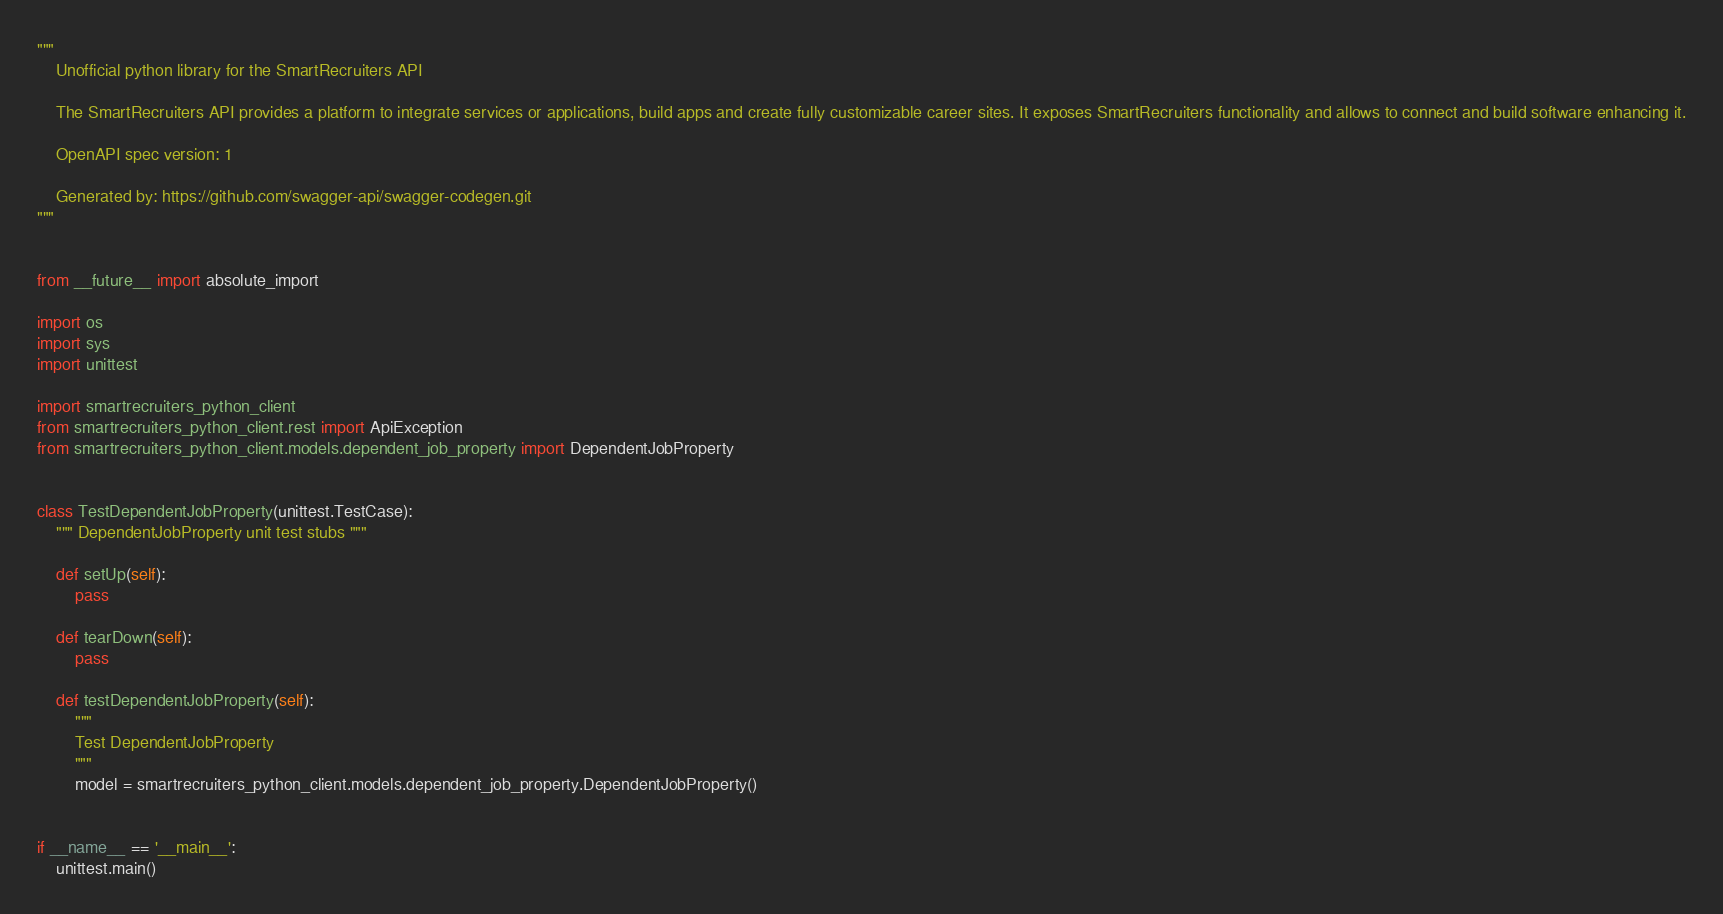<code> <loc_0><loc_0><loc_500><loc_500><_Python_>"""
    Unofficial python library for the SmartRecruiters API

    The SmartRecruiters API provides a platform to integrate services or applications, build apps and create fully customizable career sites. It exposes SmartRecruiters functionality and allows to connect and build software enhancing it.

    OpenAPI spec version: 1
    
    Generated by: https://github.com/swagger-api/swagger-codegen.git
"""


from __future__ import absolute_import

import os
import sys
import unittest

import smartrecruiters_python_client
from smartrecruiters_python_client.rest import ApiException
from smartrecruiters_python_client.models.dependent_job_property import DependentJobProperty


class TestDependentJobProperty(unittest.TestCase):
    """ DependentJobProperty unit test stubs """

    def setUp(self):
        pass

    def tearDown(self):
        pass

    def testDependentJobProperty(self):
        """
        Test DependentJobProperty
        """
        model = smartrecruiters_python_client.models.dependent_job_property.DependentJobProperty()


if __name__ == '__main__':
    unittest.main()
</code> 